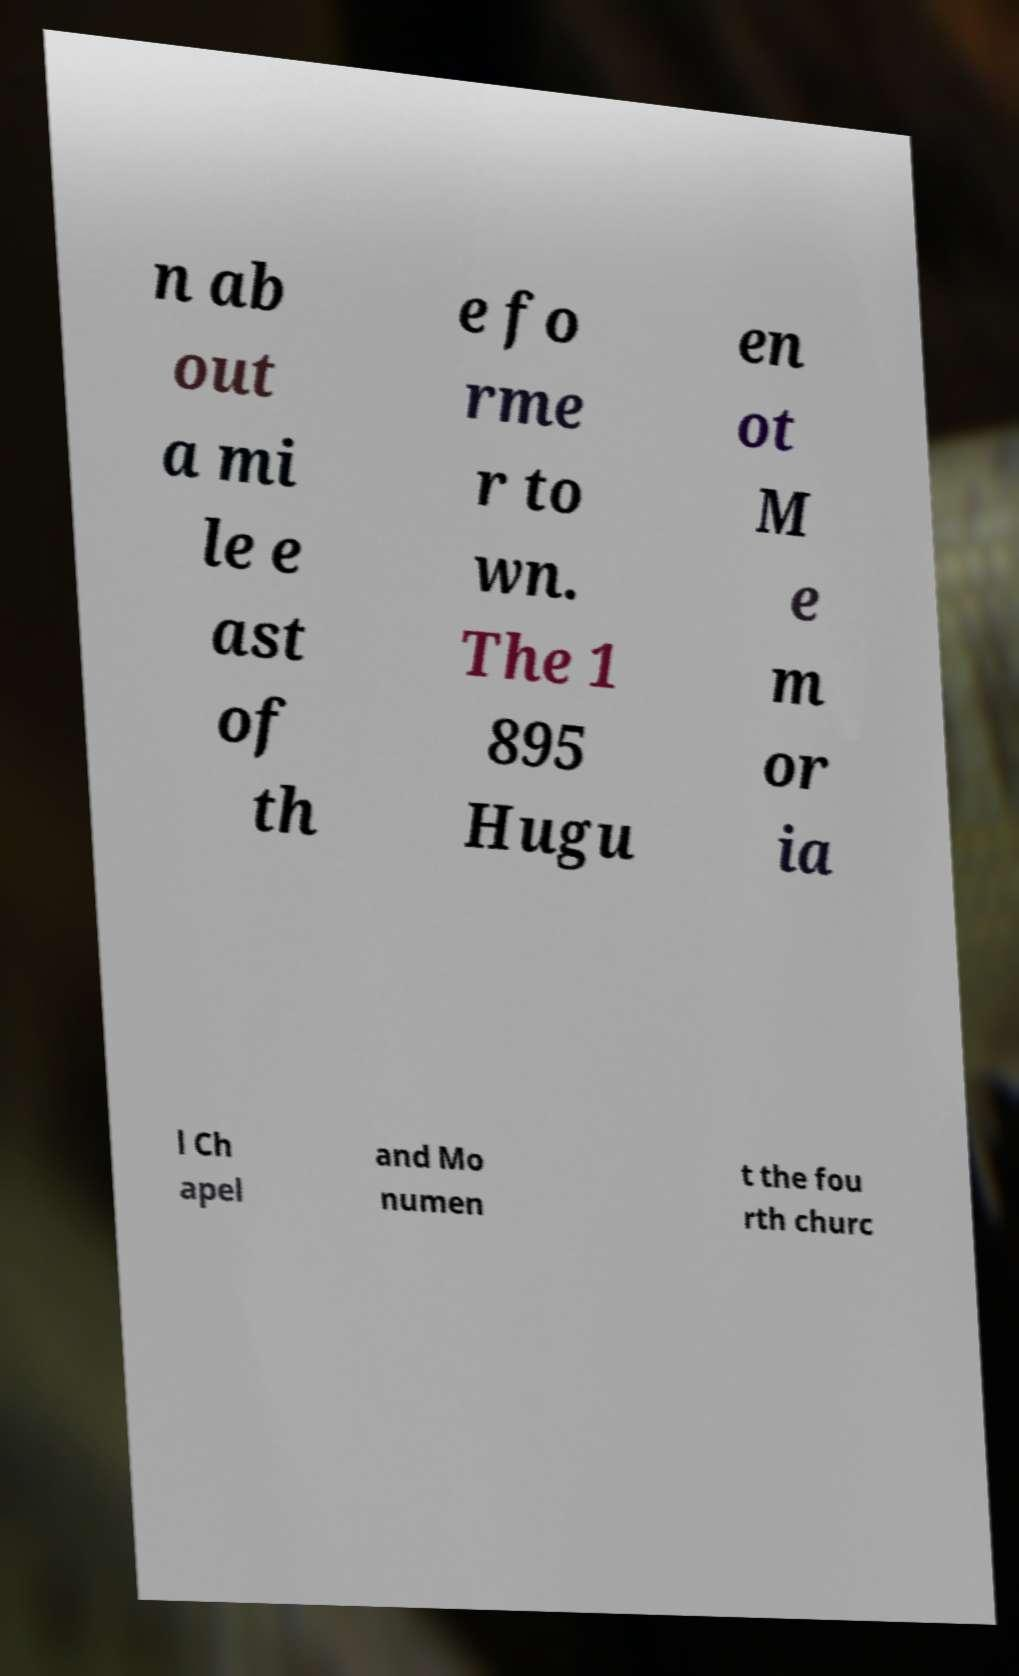What messages or text are displayed in this image? I need them in a readable, typed format. n ab out a mi le e ast of th e fo rme r to wn. The 1 895 Hugu en ot M e m or ia l Ch apel and Mo numen t the fou rth churc 